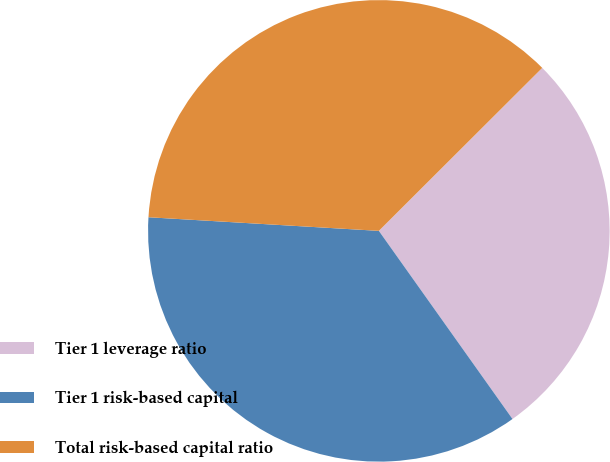Convert chart to OTSL. <chart><loc_0><loc_0><loc_500><loc_500><pie_chart><fcel>Tier 1 leverage ratio<fcel>Tier 1 risk-based capital<fcel>Total risk-based capital ratio<nl><fcel>27.65%<fcel>35.77%<fcel>36.58%<nl></chart> 